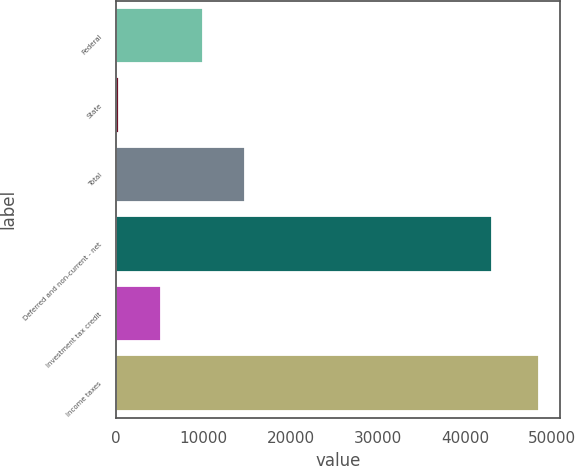<chart> <loc_0><loc_0><loc_500><loc_500><bar_chart><fcel>Federal<fcel>State<fcel>Total<fcel>Deferred and non-current - net<fcel>Investment tax credit<fcel>Income taxes<nl><fcel>9944.2<fcel>310<fcel>14761.3<fcel>43102<fcel>5127.1<fcel>48481<nl></chart> 